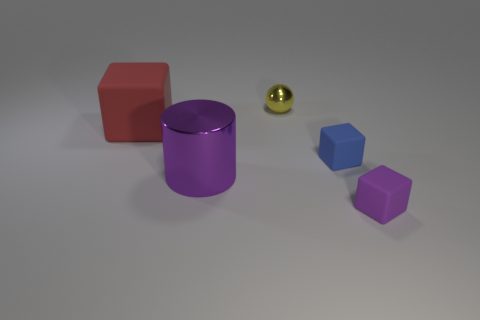Subtract all small blocks. How many blocks are left? 1 Subtract all red blocks. How many blocks are left? 2 Add 4 blue objects. How many objects exist? 9 Subtract 3 blocks. How many blocks are left? 0 Subtract all blue cubes. Subtract all small yellow spheres. How many objects are left? 3 Add 2 rubber things. How many rubber things are left? 5 Add 3 balls. How many balls exist? 4 Subtract 0 gray cylinders. How many objects are left? 5 Subtract all cubes. How many objects are left? 2 Subtract all brown cylinders. Subtract all purple balls. How many cylinders are left? 1 